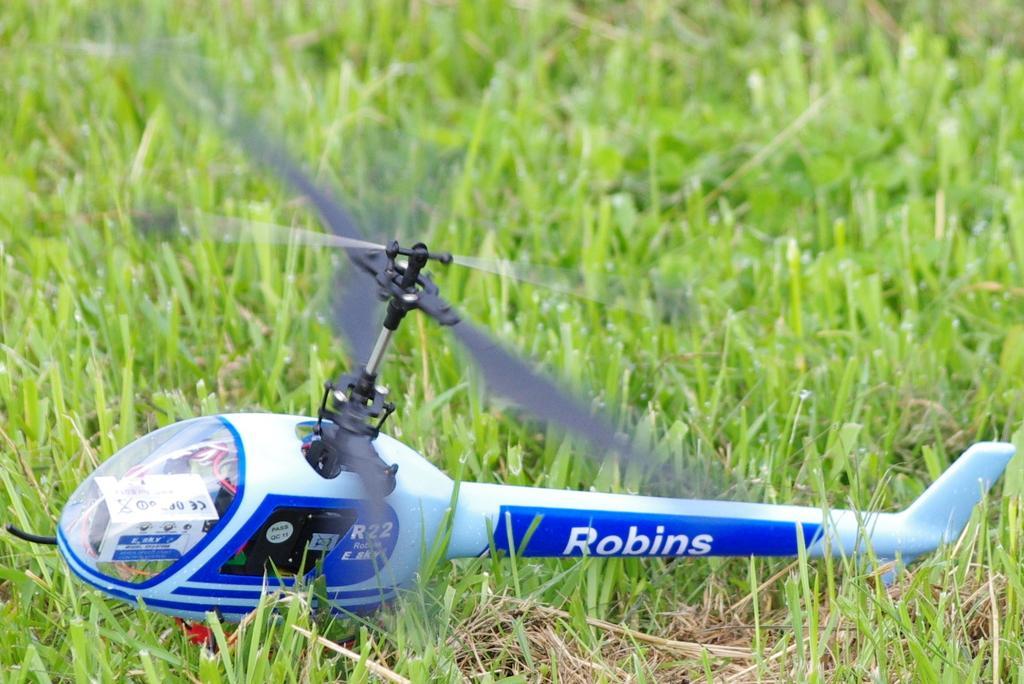How would you summarize this image in a sentence or two? There is a toy helicopter on the grassland in the foreground area of the image. 